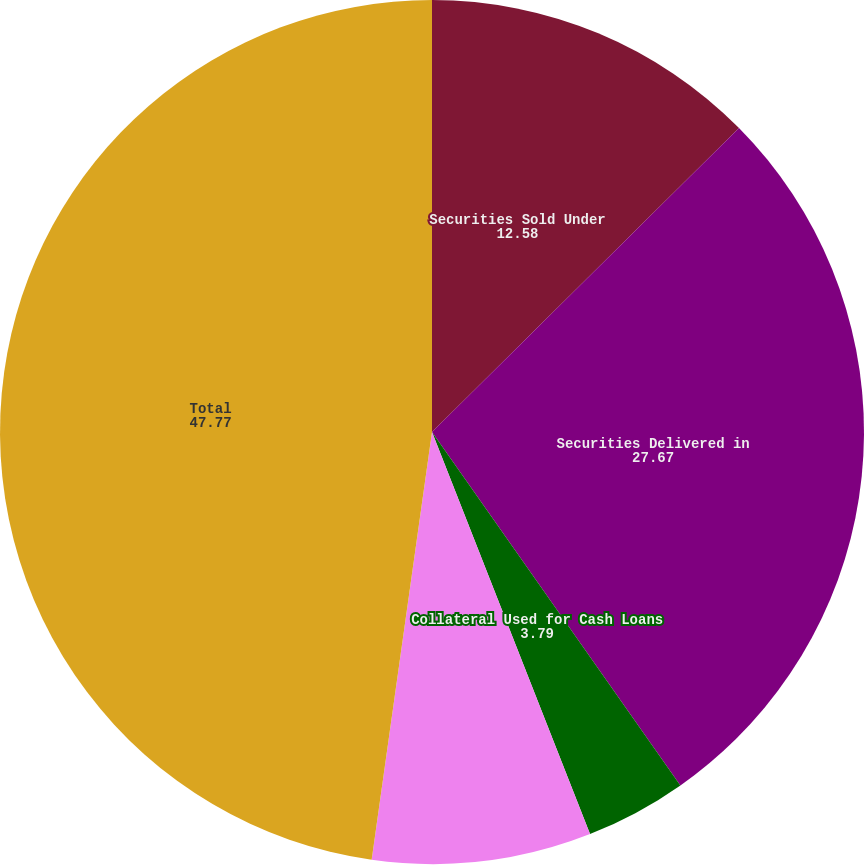Convert chart to OTSL. <chart><loc_0><loc_0><loc_500><loc_500><pie_chart><fcel>Securities Sold Under<fcel>Securities Delivered in<fcel>Collateral Used for Cash Loans<fcel>Collateral Used for Deposits<fcel>Total<nl><fcel>12.58%<fcel>27.67%<fcel>3.79%<fcel>8.19%<fcel>47.77%<nl></chart> 